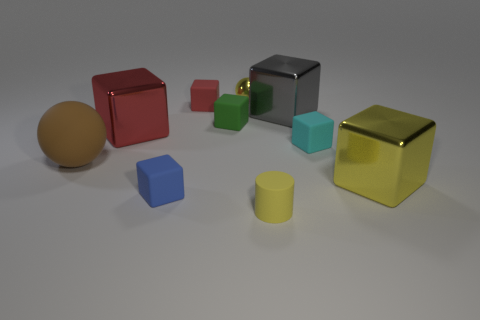There is a big thing that is the same shape as the small yellow shiny object; what is its color?
Your answer should be very brief. Brown. Are there any other things that are the same color as the matte ball?
Offer a very short reply. No. Are there more big gray metal objects than brown metal balls?
Your answer should be very brief. Yes. Are the big yellow block and the blue cube made of the same material?
Provide a succinct answer. No. How many small red things are the same material as the large brown ball?
Ensure brevity in your answer.  1. Does the rubber ball have the same size as the yellow thing that is in front of the large yellow metal block?
Give a very brief answer. No. The metallic thing that is both left of the yellow cylinder and behind the big red cube is what color?
Offer a terse response. Yellow. There is a tiny rubber block that is right of the tiny green rubber cube; is there a small yellow matte thing that is behind it?
Your response must be concise. No. Are there an equal number of tiny cyan objects left of the yellow matte cylinder and large cyan rubber spheres?
Provide a succinct answer. Yes. There is a tiny yellow object in front of the yellow object on the left side of the tiny cylinder; how many big yellow metal things are on the right side of it?
Keep it short and to the point. 1. 